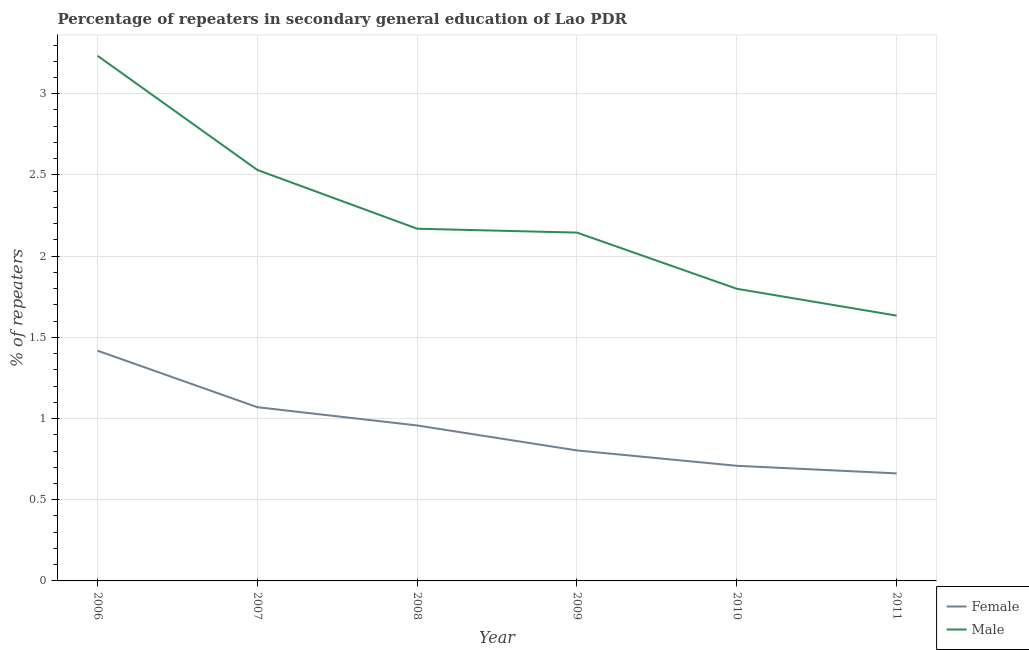Does the line corresponding to percentage of male repeaters intersect with the line corresponding to percentage of female repeaters?
Give a very brief answer. No. Is the number of lines equal to the number of legend labels?
Offer a very short reply. Yes. What is the percentage of male repeaters in 2010?
Ensure brevity in your answer.  1.8. Across all years, what is the maximum percentage of male repeaters?
Provide a succinct answer. 3.23. Across all years, what is the minimum percentage of male repeaters?
Provide a short and direct response. 1.63. In which year was the percentage of female repeaters minimum?
Offer a terse response. 2011. What is the total percentage of female repeaters in the graph?
Provide a succinct answer. 5.62. What is the difference between the percentage of female repeaters in 2007 and that in 2008?
Offer a terse response. 0.11. What is the difference between the percentage of female repeaters in 2008 and the percentage of male repeaters in 2007?
Give a very brief answer. -1.57. What is the average percentage of female repeaters per year?
Your answer should be very brief. 0.94. In the year 2009, what is the difference between the percentage of female repeaters and percentage of male repeaters?
Ensure brevity in your answer.  -1.34. What is the ratio of the percentage of male repeaters in 2007 to that in 2010?
Keep it short and to the point. 1.41. Is the difference between the percentage of female repeaters in 2010 and 2011 greater than the difference between the percentage of male repeaters in 2010 and 2011?
Your response must be concise. No. What is the difference between the highest and the second highest percentage of male repeaters?
Offer a very short reply. 0.7. What is the difference between the highest and the lowest percentage of female repeaters?
Keep it short and to the point. 0.76. In how many years, is the percentage of female repeaters greater than the average percentage of female repeaters taken over all years?
Your answer should be very brief. 3. Is the sum of the percentage of female repeaters in 2007 and 2008 greater than the maximum percentage of male repeaters across all years?
Offer a terse response. No. Is the percentage of male repeaters strictly greater than the percentage of female repeaters over the years?
Provide a short and direct response. Yes. Is the percentage of female repeaters strictly less than the percentage of male repeaters over the years?
Give a very brief answer. Yes. How many lines are there?
Ensure brevity in your answer.  2. How many years are there in the graph?
Your answer should be compact. 6. What is the difference between two consecutive major ticks on the Y-axis?
Provide a succinct answer. 0.5. Does the graph contain any zero values?
Ensure brevity in your answer.  No. Does the graph contain grids?
Your response must be concise. Yes. How many legend labels are there?
Offer a terse response. 2. How are the legend labels stacked?
Offer a terse response. Vertical. What is the title of the graph?
Provide a succinct answer. Percentage of repeaters in secondary general education of Lao PDR. Does "Methane emissions" appear as one of the legend labels in the graph?
Ensure brevity in your answer.  No. What is the label or title of the X-axis?
Your answer should be very brief. Year. What is the label or title of the Y-axis?
Provide a succinct answer. % of repeaters. What is the % of repeaters in Female in 2006?
Your answer should be compact. 1.42. What is the % of repeaters of Male in 2006?
Your response must be concise. 3.23. What is the % of repeaters of Female in 2007?
Ensure brevity in your answer.  1.07. What is the % of repeaters of Male in 2007?
Your response must be concise. 2.53. What is the % of repeaters in Female in 2008?
Keep it short and to the point. 0.96. What is the % of repeaters of Male in 2008?
Your response must be concise. 2.17. What is the % of repeaters in Female in 2009?
Make the answer very short. 0.8. What is the % of repeaters in Male in 2009?
Your response must be concise. 2.14. What is the % of repeaters in Female in 2010?
Offer a very short reply. 0.71. What is the % of repeaters of Male in 2010?
Your response must be concise. 1.8. What is the % of repeaters in Female in 2011?
Provide a succinct answer. 0.66. What is the % of repeaters in Male in 2011?
Offer a terse response. 1.63. Across all years, what is the maximum % of repeaters in Female?
Provide a succinct answer. 1.42. Across all years, what is the maximum % of repeaters in Male?
Give a very brief answer. 3.23. Across all years, what is the minimum % of repeaters in Female?
Offer a very short reply. 0.66. Across all years, what is the minimum % of repeaters in Male?
Provide a succinct answer. 1.63. What is the total % of repeaters in Female in the graph?
Your response must be concise. 5.62. What is the total % of repeaters of Male in the graph?
Provide a succinct answer. 13.51. What is the difference between the % of repeaters in Female in 2006 and that in 2007?
Your response must be concise. 0.35. What is the difference between the % of repeaters of Male in 2006 and that in 2007?
Your answer should be compact. 0.7. What is the difference between the % of repeaters of Female in 2006 and that in 2008?
Make the answer very short. 0.46. What is the difference between the % of repeaters of Male in 2006 and that in 2008?
Your answer should be very brief. 1.06. What is the difference between the % of repeaters in Female in 2006 and that in 2009?
Your response must be concise. 0.61. What is the difference between the % of repeaters of Male in 2006 and that in 2009?
Keep it short and to the point. 1.09. What is the difference between the % of repeaters of Female in 2006 and that in 2010?
Ensure brevity in your answer.  0.71. What is the difference between the % of repeaters of Male in 2006 and that in 2010?
Make the answer very short. 1.44. What is the difference between the % of repeaters in Female in 2006 and that in 2011?
Your answer should be compact. 0.76. What is the difference between the % of repeaters of Male in 2006 and that in 2011?
Provide a succinct answer. 1.6. What is the difference between the % of repeaters of Female in 2007 and that in 2008?
Ensure brevity in your answer.  0.11. What is the difference between the % of repeaters in Male in 2007 and that in 2008?
Offer a very short reply. 0.36. What is the difference between the % of repeaters of Female in 2007 and that in 2009?
Keep it short and to the point. 0.27. What is the difference between the % of repeaters of Male in 2007 and that in 2009?
Give a very brief answer. 0.39. What is the difference between the % of repeaters of Female in 2007 and that in 2010?
Your response must be concise. 0.36. What is the difference between the % of repeaters in Male in 2007 and that in 2010?
Your response must be concise. 0.73. What is the difference between the % of repeaters in Female in 2007 and that in 2011?
Make the answer very short. 0.41. What is the difference between the % of repeaters of Male in 2007 and that in 2011?
Your response must be concise. 0.9. What is the difference between the % of repeaters of Female in 2008 and that in 2009?
Keep it short and to the point. 0.15. What is the difference between the % of repeaters in Male in 2008 and that in 2009?
Ensure brevity in your answer.  0.02. What is the difference between the % of repeaters of Female in 2008 and that in 2010?
Your answer should be compact. 0.25. What is the difference between the % of repeaters in Male in 2008 and that in 2010?
Offer a terse response. 0.37. What is the difference between the % of repeaters in Female in 2008 and that in 2011?
Your response must be concise. 0.3. What is the difference between the % of repeaters in Male in 2008 and that in 2011?
Provide a short and direct response. 0.54. What is the difference between the % of repeaters in Female in 2009 and that in 2010?
Your answer should be compact. 0.09. What is the difference between the % of repeaters in Male in 2009 and that in 2010?
Your answer should be very brief. 0.35. What is the difference between the % of repeaters in Female in 2009 and that in 2011?
Your answer should be very brief. 0.14. What is the difference between the % of repeaters in Male in 2009 and that in 2011?
Keep it short and to the point. 0.51. What is the difference between the % of repeaters in Female in 2010 and that in 2011?
Keep it short and to the point. 0.05. What is the difference between the % of repeaters in Male in 2010 and that in 2011?
Offer a very short reply. 0.17. What is the difference between the % of repeaters of Female in 2006 and the % of repeaters of Male in 2007?
Give a very brief answer. -1.11. What is the difference between the % of repeaters in Female in 2006 and the % of repeaters in Male in 2008?
Offer a terse response. -0.75. What is the difference between the % of repeaters of Female in 2006 and the % of repeaters of Male in 2009?
Offer a very short reply. -0.73. What is the difference between the % of repeaters of Female in 2006 and the % of repeaters of Male in 2010?
Make the answer very short. -0.38. What is the difference between the % of repeaters of Female in 2006 and the % of repeaters of Male in 2011?
Provide a short and direct response. -0.22. What is the difference between the % of repeaters in Female in 2007 and the % of repeaters in Male in 2008?
Ensure brevity in your answer.  -1.1. What is the difference between the % of repeaters of Female in 2007 and the % of repeaters of Male in 2009?
Keep it short and to the point. -1.08. What is the difference between the % of repeaters of Female in 2007 and the % of repeaters of Male in 2010?
Your response must be concise. -0.73. What is the difference between the % of repeaters of Female in 2007 and the % of repeaters of Male in 2011?
Your answer should be very brief. -0.56. What is the difference between the % of repeaters in Female in 2008 and the % of repeaters in Male in 2009?
Offer a very short reply. -1.19. What is the difference between the % of repeaters of Female in 2008 and the % of repeaters of Male in 2010?
Make the answer very short. -0.84. What is the difference between the % of repeaters of Female in 2008 and the % of repeaters of Male in 2011?
Your answer should be very brief. -0.68. What is the difference between the % of repeaters in Female in 2009 and the % of repeaters in Male in 2010?
Your answer should be compact. -1. What is the difference between the % of repeaters in Female in 2009 and the % of repeaters in Male in 2011?
Your response must be concise. -0.83. What is the difference between the % of repeaters of Female in 2010 and the % of repeaters of Male in 2011?
Your answer should be compact. -0.92. What is the average % of repeaters in Female per year?
Make the answer very short. 0.94. What is the average % of repeaters of Male per year?
Give a very brief answer. 2.25. In the year 2006, what is the difference between the % of repeaters of Female and % of repeaters of Male?
Offer a very short reply. -1.82. In the year 2007, what is the difference between the % of repeaters in Female and % of repeaters in Male?
Offer a terse response. -1.46. In the year 2008, what is the difference between the % of repeaters of Female and % of repeaters of Male?
Ensure brevity in your answer.  -1.21. In the year 2009, what is the difference between the % of repeaters of Female and % of repeaters of Male?
Provide a short and direct response. -1.34. In the year 2010, what is the difference between the % of repeaters of Female and % of repeaters of Male?
Your answer should be compact. -1.09. In the year 2011, what is the difference between the % of repeaters of Female and % of repeaters of Male?
Your answer should be very brief. -0.97. What is the ratio of the % of repeaters of Female in 2006 to that in 2007?
Ensure brevity in your answer.  1.33. What is the ratio of the % of repeaters of Male in 2006 to that in 2007?
Your answer should be compact. 1.28. What is the ratio of the % of repeaters in Female in 2006 to that in 2008?
Your answer should be very brief. 1.48. What is the ratio of the % of repeaters in Male in 2006 to that in 2008?
Make the answer very short. 1.49. What is the ratio of the % of repeaters in Female in 2006 to that in 2009?
Provide a short and direct response. 1.76. What is the ratio of the % of repeaters of Male in 2006 to that in 2009?
Offer a very short reply. 1.51. What is the ratio of the % of repeaters of Female in 2006 to that in 2010?
Keep it short and to the point. 2. What is the ratio of the % of repeaters in Male in 2006 to that in 2010?
Your answer should be compact. 1.8. What is the ratio of the % of repeaters of Female in 2006 to that in 2011?
Make the answer very short. 2.14. What is the ratio of the % of repeaters of Male in 2006 to that in 2011?
Give a very brief answer. 1.98. What is the ratio of the % of repeaters in Female in 2007 to that in 2008?
Your response must be concise. 1.12. What is the ratio of the % of repeaters in Male in 2007 to that in 2008?
Your answer should be very brief. 1.17. What is the ratio of the % of repeaters in Female in 2007 to that in 2009?
Offer a very short reply. 1.33. What is the ratio of the % of repeaters of Male in 2007 to that in 2009?
Ensure brevity in your answer.  1.18. What is the ratio of the % of repeaters of Female in 2007 to that in 2010?
Give a very brief answer. 1.51. What is the ratio of the % of repeaters of Male in 2007 to that in 2010?
Provide a short and direct response. 1.41. What is the ratio of the % of repeaters in Female in 2007 to that in 2011?
Offer a terse response. 1.62. What is the ratio of the % of repeaters in Male in 2007 to that in 2011?
Keep it short and to the point. 1.55. What is the ratio of the % of repeaters of Female in 2008 to that in 2009?
Offer a very short reply. 1.19. What is the ratio of the % of repeaters of Male in 2008 to that in 2009?
Provide a succinct answer. 1.01. What is the ratio of the % of repeaters of Female in 2008 to that in 2010?
Your answer should be compact. 1.35. What is the ratio of the % of repeaters in Male in 2008 to that in 2010?
Make the answer very short. 1.21. What is the ratio of the % of repeaters of Female in 2008 to that in 2011?
Ensure brevity in your answer.  1.45. What is the ratio of the % of repeaters of Male in 2008 to that in 2011?
Keep it short and to the point. 1.33. What is the ratio of the % of repeaters of Female in 2009 to that in 2010?
Offer a terse response. 1.13. What is the ratio of the % of repeaters in Male in 2009 to that in 2010?
Keep it short and to the point. 1.19. What is the ratio of the % of repeaters of Female in 2009 to that in 2011?
Provide a succinct answer. 1.21. What is the ratio of the % of repeaters in Male in 2009 to that in 2011?
Give a very brief answer. 1.31. What is the ratio of the % of repeaters of Female in 2010 to that in 2011?
Give a very brief answer. 1.07. What is the ratio of the % of repeaters in Male in 2010 to that in 2011?
Your answer should be very brief. 1.1. What is the difference between the highest and the second highest % of repeaters in Female?
Your answer should be very brief. 0.35. What is the difference between the highest and the second highest % of repeaters of Male?
Ensure brevity in your answer.  0.7. What is the difference between the highest and the lowest % of repeaters in Female?
Keep it short and to the point. 0.76. What is the difference between the highest and the lowest % of repeaters in Male?
Provide a succinct answer. 1.6. 